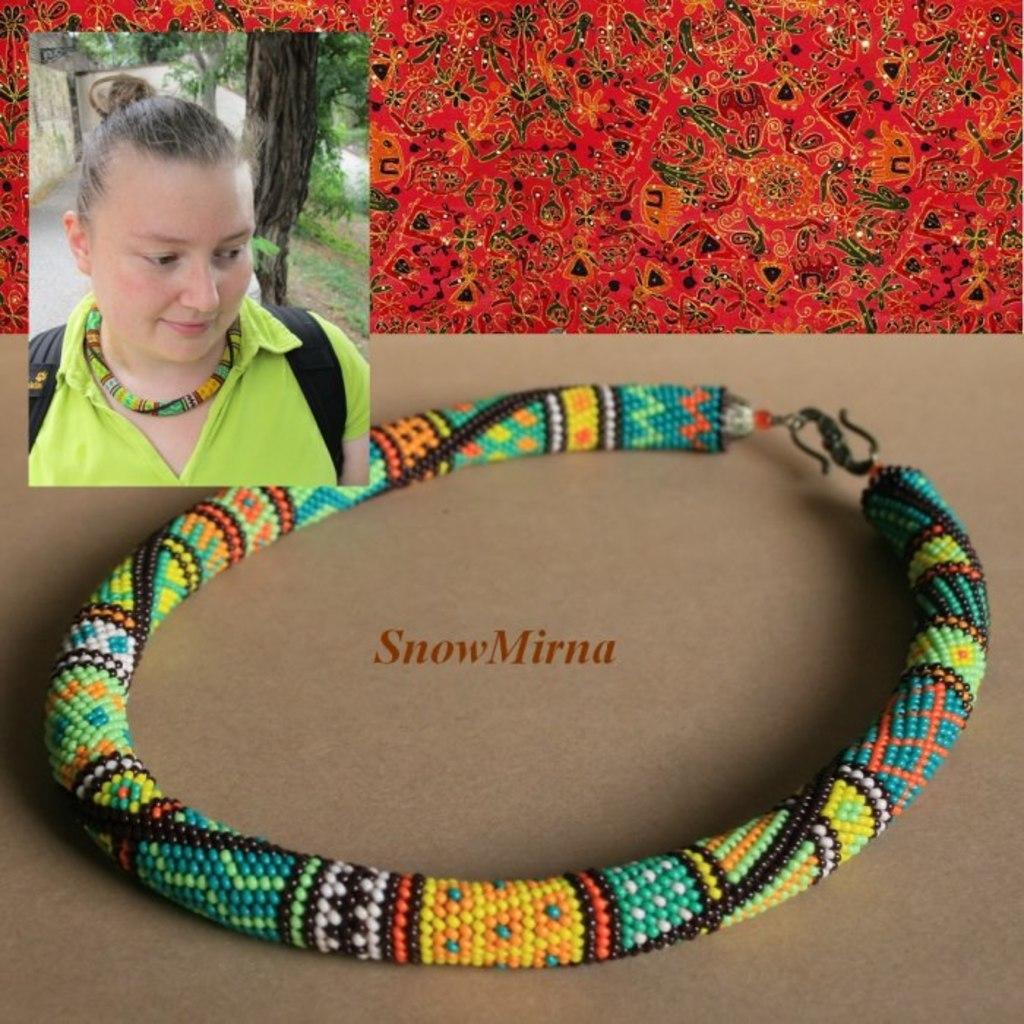In one or two sentences, can you explain what this image depicts? In this image I can see a necklace with colorful beads displayed on a table with some text in the center. In the top left corner, I can see a woman wearing this necklace. At the top of the image I can see design sticker. 